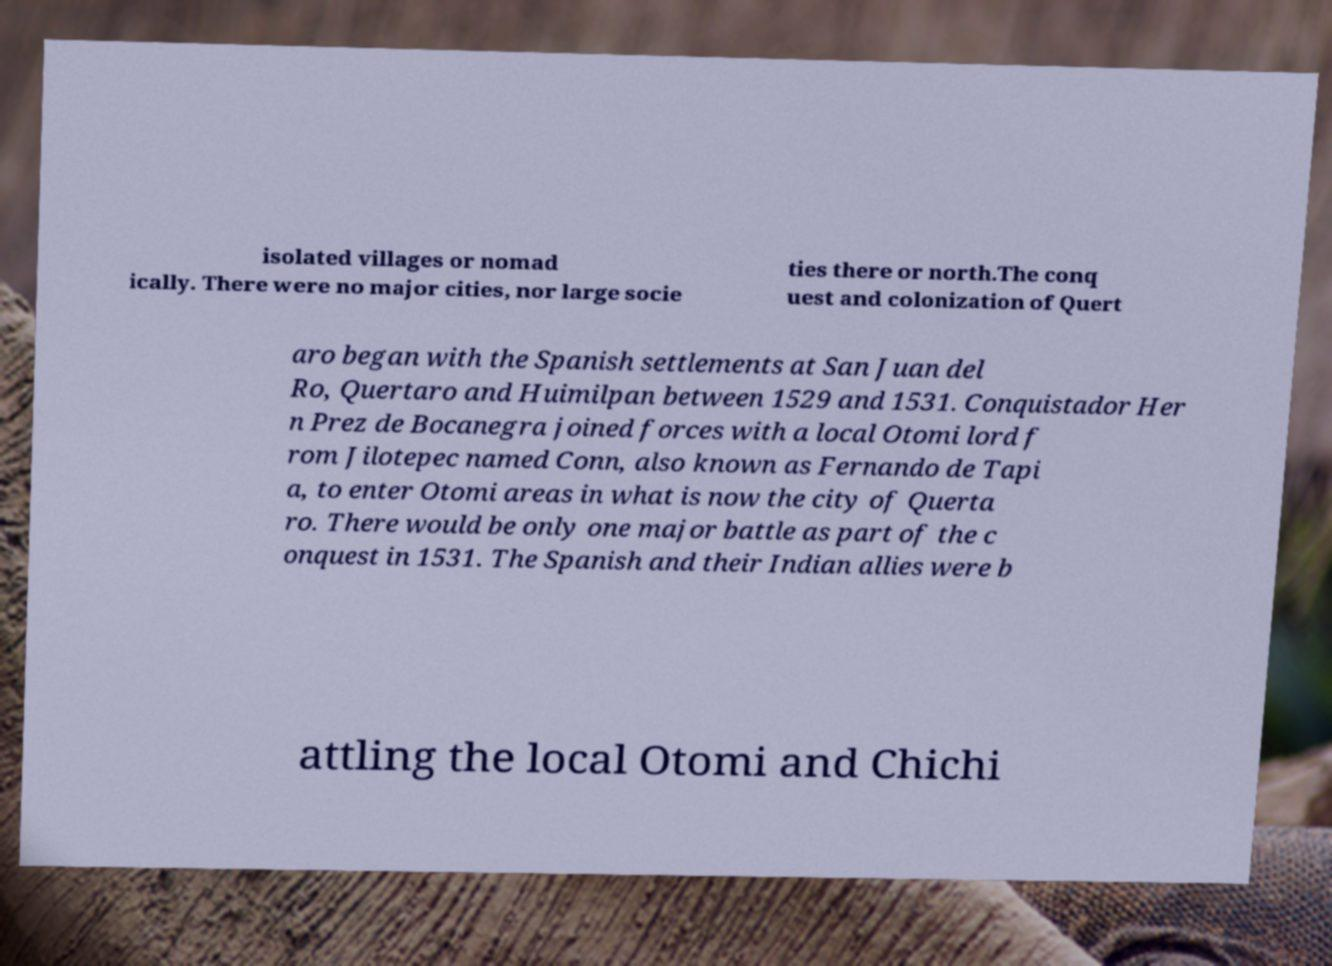Could you extract and type out the text from this image? isolated villages or nomad ically. There were no major cities, nor large socie ties there or north.The conq uest and colonization of Quert aro began with the Spanish settlements at San Juan del Ro, Quertaro and Huimilpan between 1529 and 1531. Conquistador Her n Prez de Bocanegra joined forces with a local Otomi lord f rom Jilotepec named Conn, also known as Fernando de Tapi a, to enter Otomi areas in what is now the city of Querta ro. There would be only one major battle as part of the c onquest in 1531. The Spanish and their Indian allies were b attling the local Otomi and Chichi 